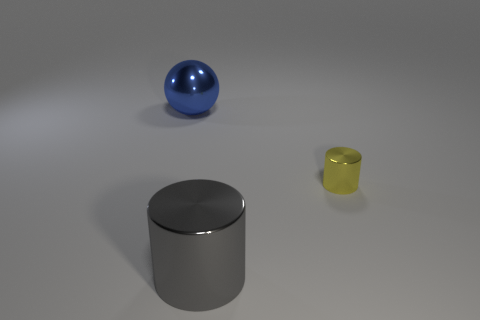What number of other objects are the same size as the yellow metallic thing?
Ensure brevity in your answer.  0. What number of things are the same color as the big cylinder?
Offer a very short reply. 0. The large blue thing is what shape?
Provide a succinct answer. Sphere. What color is the metallic object that is to the right of the large shiny ball and left of the yellow shiny cylinder?
Provide a short and direct response. Gray. What is the material of the big cylinder?
Make the answer very short. Metal. What is the shape of the large blue shiny thing that is behind the yellow object?
Offer a terse response. Sphere. There is a thing that is the same size as the gray metallic cylinder; what color is it?
Keep it short and to the point. Blue. Does the big object that is right of the big ball have the same material as the small cylinder?
Ensure brevity in your answer.  Yes. What is the size of the object that is on the left side of the tiny metallic object and in front of the blue thing?
Give a very brief answer. Large. There is a cylinder that is in front of the tiny metal cylinder; what size is it?
Your answer should be very brief. Large. 